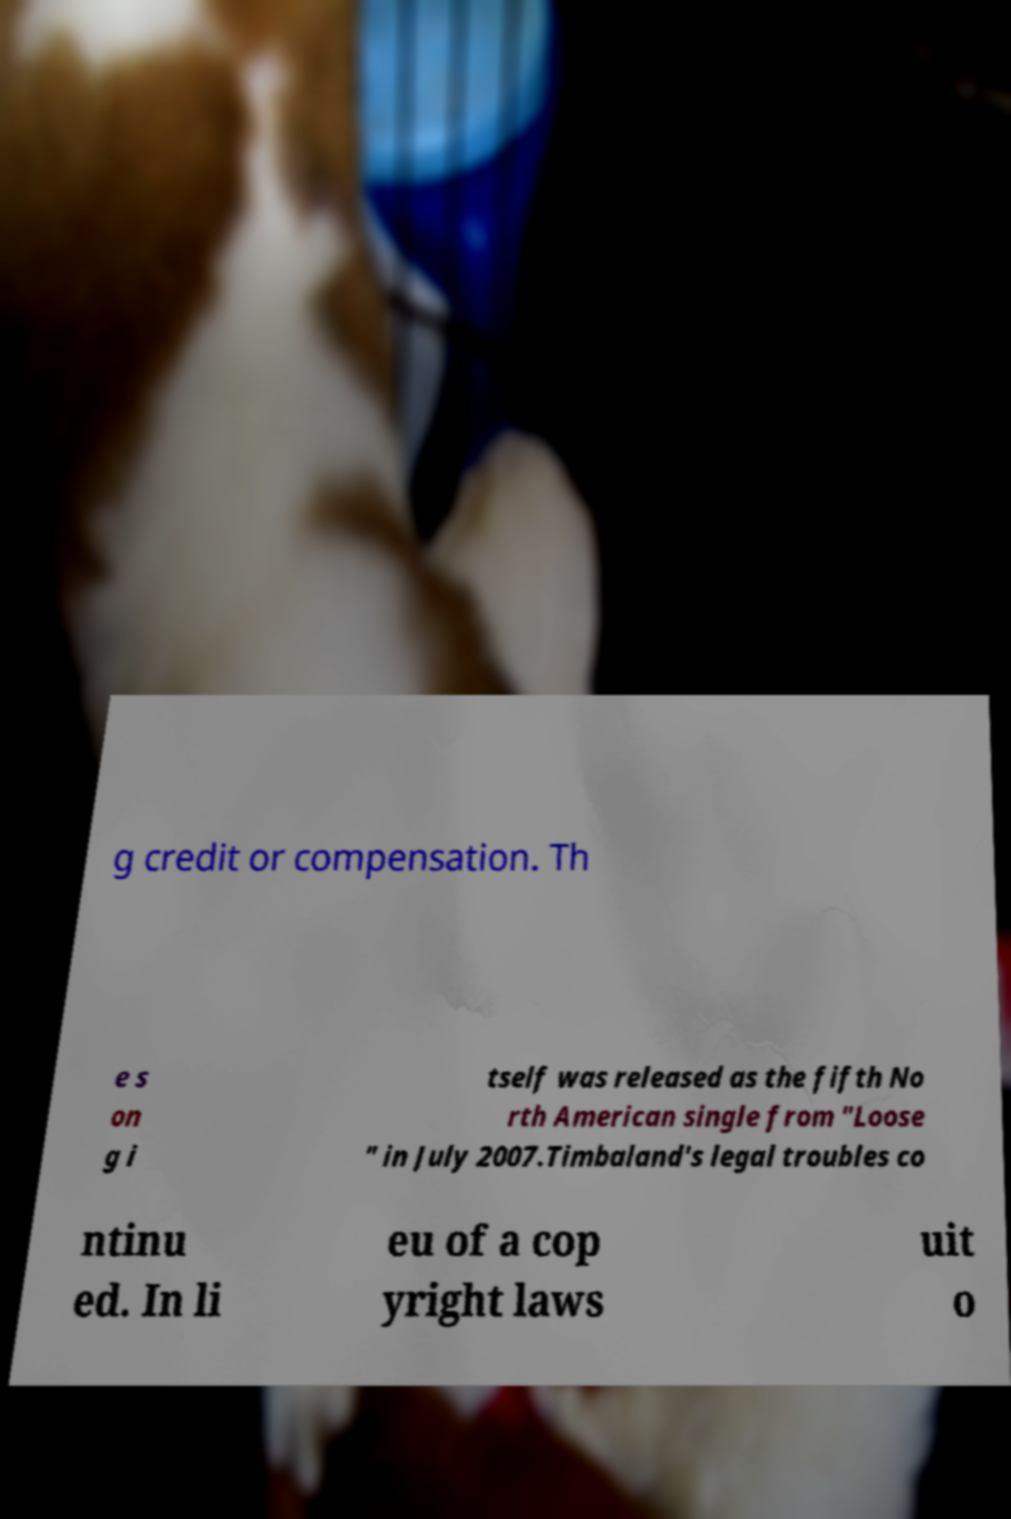There's text embedded in this image that I need extracted. Can you transcribe it verbatim? g credit or compensation. Th e s on g i tself was released as the fifth No rth American single from "Loose " in July 2007.Timbaland's legal troubles co ntinu ed. In li eu of a cop yright laws uit o 